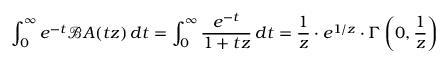<formula> <loc_0><loc_0><loc_500><loc_500>\int _ { 0 } ^ { \infty } e ^ { - t } { \mathcal { B } } A ( t z ) \, d t = \int _ { 0 } ^ { \infty } { \frac { e ^ { - t } } { 1 + t z } } \, d t = { \frac { 1 } { z } } \cdot e ^ { 1 / z } \cdot \Gamma \left ( 0 , { \frac { 1 } { z } } \right )</formula> 